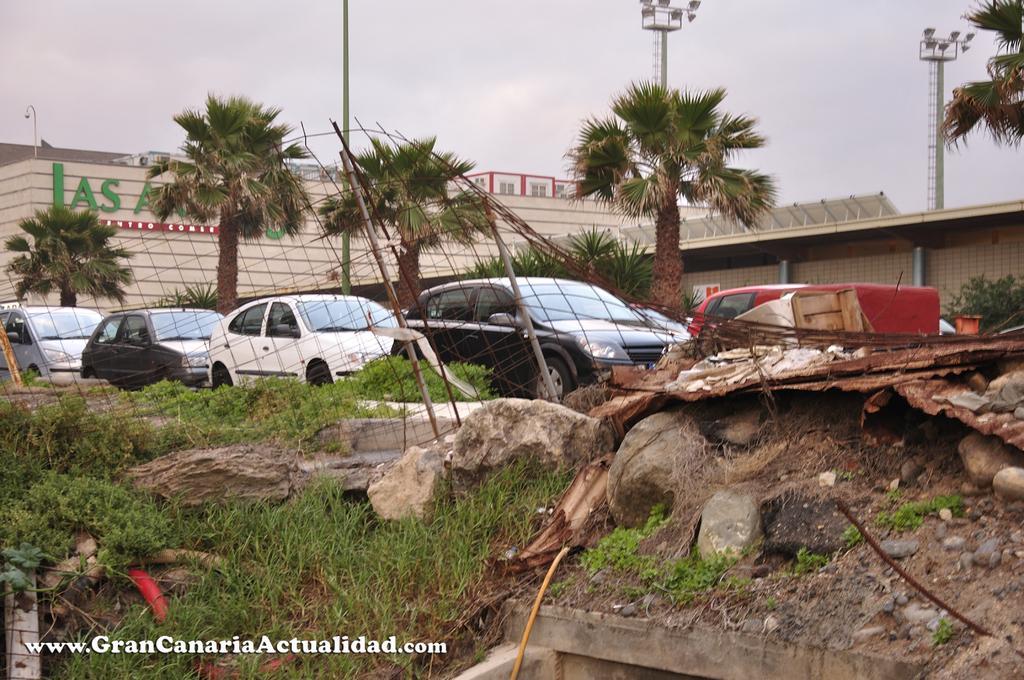Could you give a brief overview of what you see in this image? In this image in front there is grass and there are stones. In the center there are vehicles and in the background there are trees and there are buildings and poles and the sky is cloudy. 